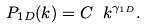<formula> <loc_0><loc_0><loc_500><loc_500>P _ { 1 D } ( k ) = C \ k ^ { \gamma _ { 1 D } } .</formula> 